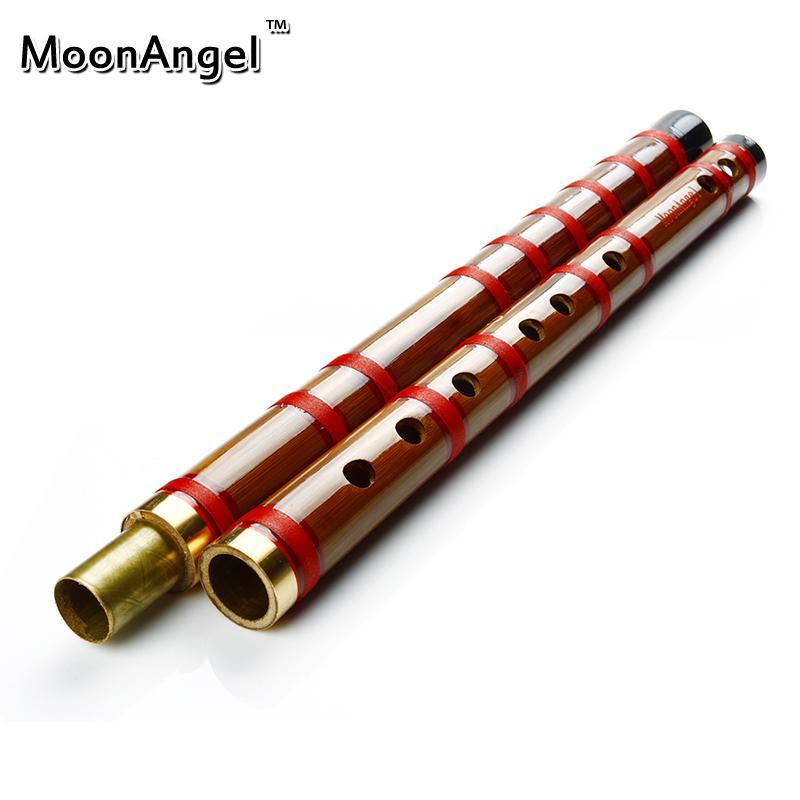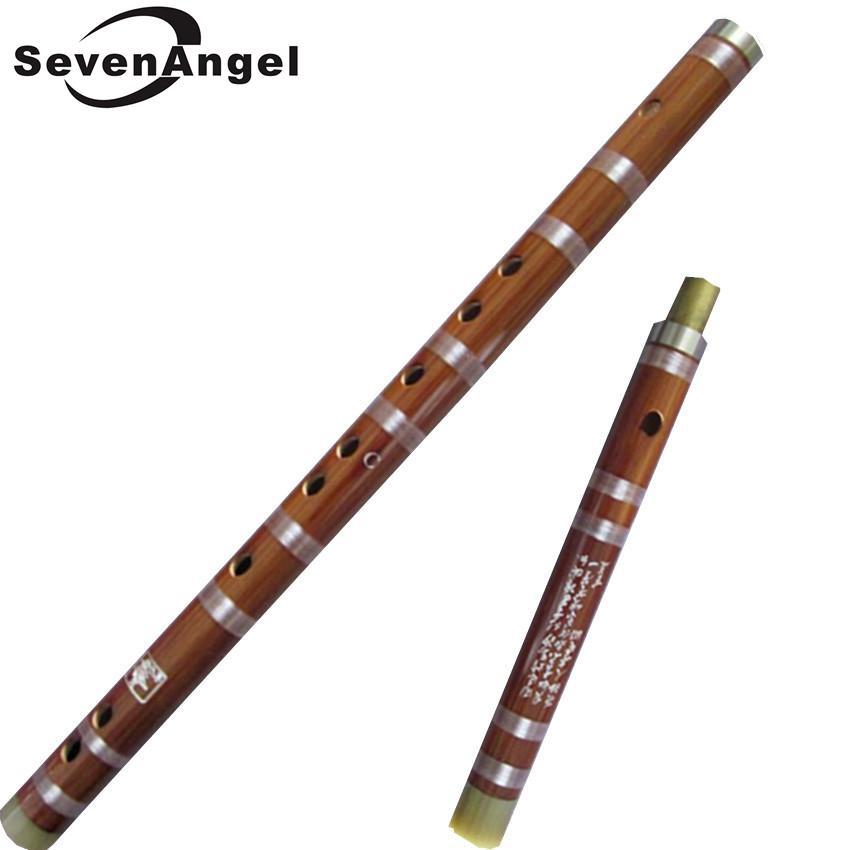The first image is the image on the left, the second image is the image on the right. Assess this claim about the two images: "Each image contains one flute, which is displayed horizontally and has a red tassel at one end.". Correct or not? Answer yes or no. No. The first image is the image on the left, the second image is the image on the right. Analyze the images presented: Is the assertion "The left and right image contains the same number of flutes with red tassels." valid? Answer yes or no. No. 